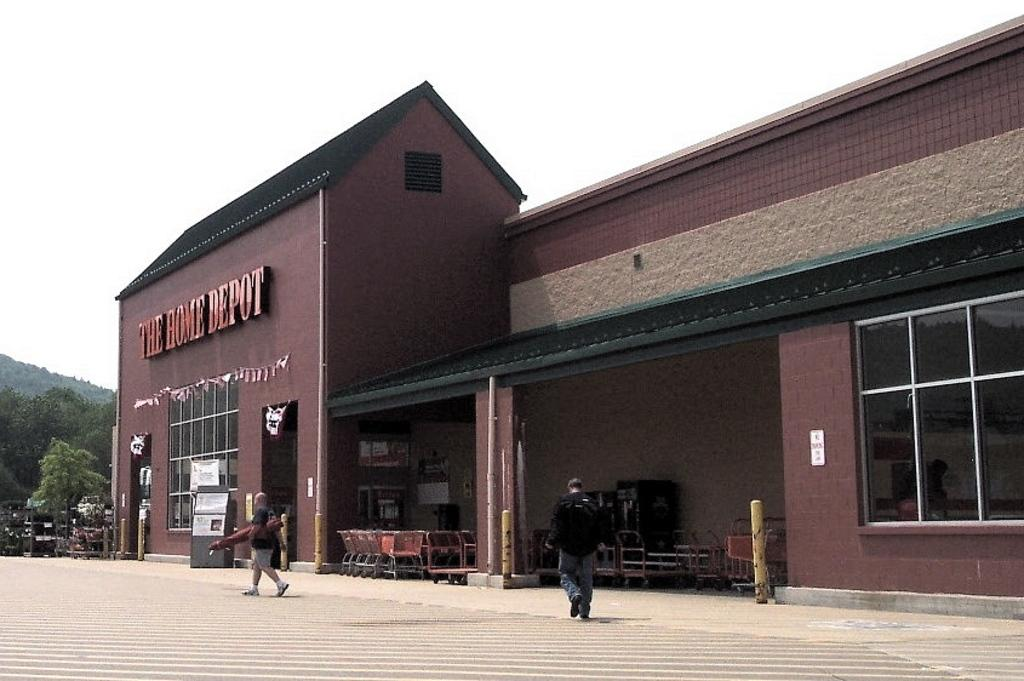What is the main structure in the center of the image? There is a building in the center of the image. What can be seen happening in the foreground of the image? People are walking on the road in the foreground. What type of vegetation is on the left side of the image? There are trees on the left side of the image. What else is present on the left side of the image? Vehicles are present on the left side of the image. How would you describe the weather in the image? The sky is clear and it is sunny in the image. What language is being spoken by the trees in the image? Trees do not speak any language, so this question cannot be answered. 